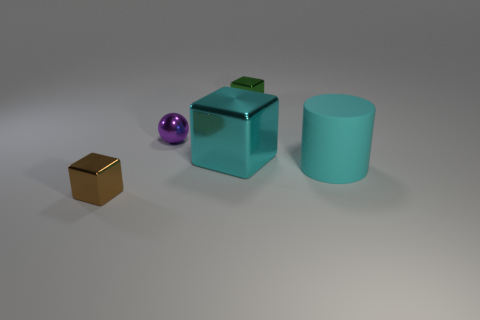Add 1 purple rubber objects. How many objects exist? 6 Subtract all cubes. How many objects are left? 2 Subtract all big cyan metal blocks. Subtract all tiny metal cubes. How many objects are left? 2 Add 1 purple objects. How many purple objects are left? 2 Add 2 green metallic cubes. How many green metallic cubes exist? 3 Subtract 0 gray blocks. How many objects are left? 5 